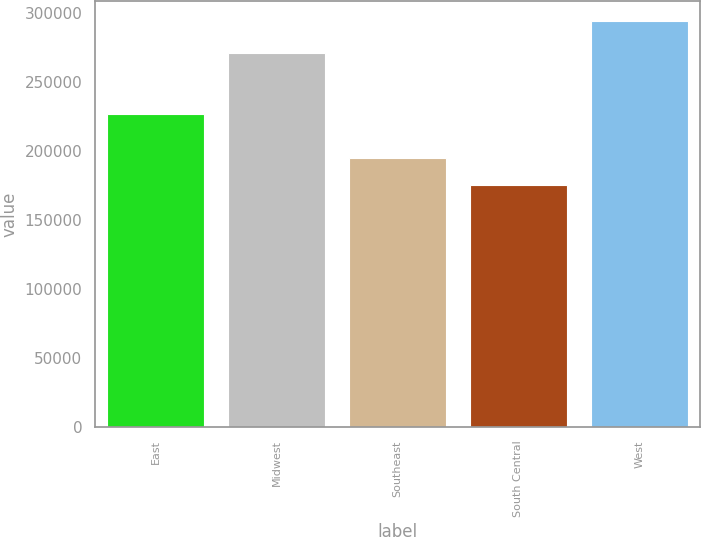Convert chart to OTSL. <chart><loc_0><loc_0><loc_500><loc_500><bar_chart><fcel>East<fcel>Midwest<fcel>Southeast<fcel>South Central<fcel>West<nl><fcel>226900<fcel>271300<fcel>195100<fcel>175600<fcel>294300<nl></chart> 